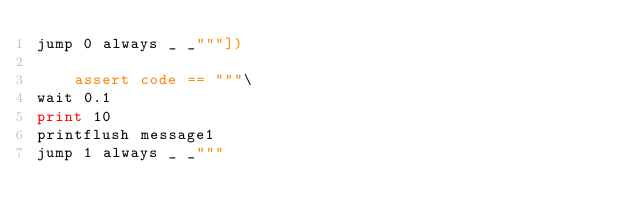Convert code to text. <code><loc_0><loc_0><loc_500><loc_500><_Python_>jump 0 always _ _"""])

    assert code == """\
wait 0.1
print 10
printflush message1
jump 1 always _ _"""
</code> 